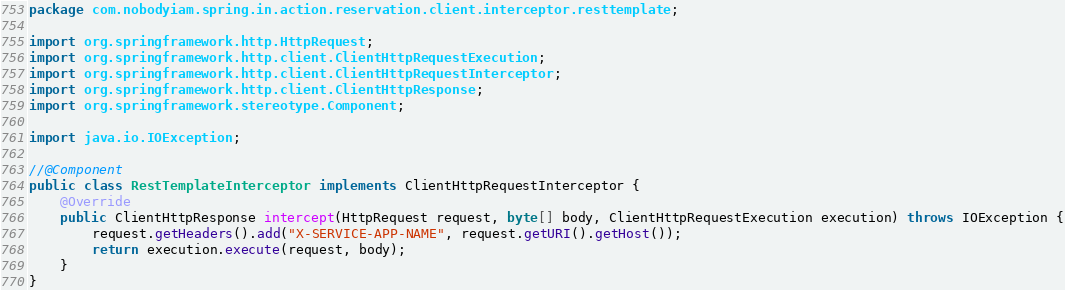Convert code to text. <code><loc_0><loc_0><loc_500><loc_500><_Java_>package com.nobodyiam.spring.in.action.reservation.client.interceptor.resttemplate;

import org.springframework.http.HttpRequest;
import org.springframework.http.client.ClientHttpRequestExecution;
import org.springframework.http.client.ClientHttpRequestInterceptor;
import org.springframework.http.client.ClientHttpResponse;
import org.springframework.stereotype.Component;

import java.io.IOException;

//@Component
public class RestTemplateInterceptor implements ClientHttpRequestInterceptor {
    @Override
    public ClientHttpResponse intercept(HttpRequest request, byte[] body, ClientHttpRequestExecution execution) throws IOException {
        request.getHeaders().add("X-SERVICE-APP-NAME", request.getURI().getHost());
        return execution.execute(request, body);
    }
}
</code> 